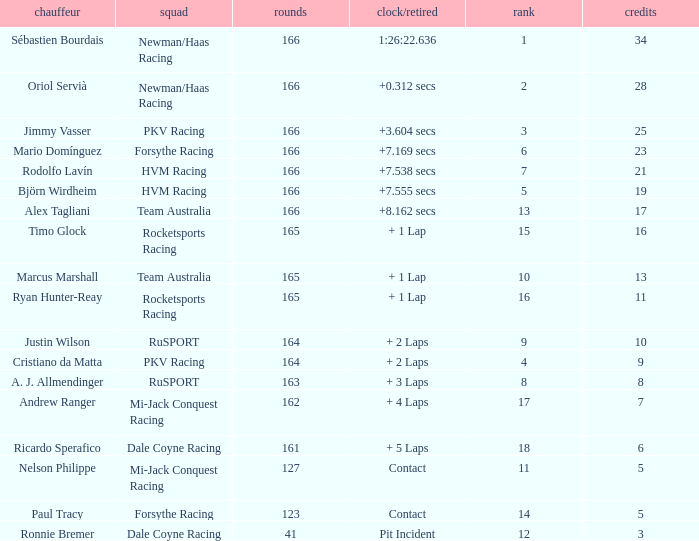What is the biggest points when the grid is less than 13 and the time/retired is +7.538 secs? 21.0. 